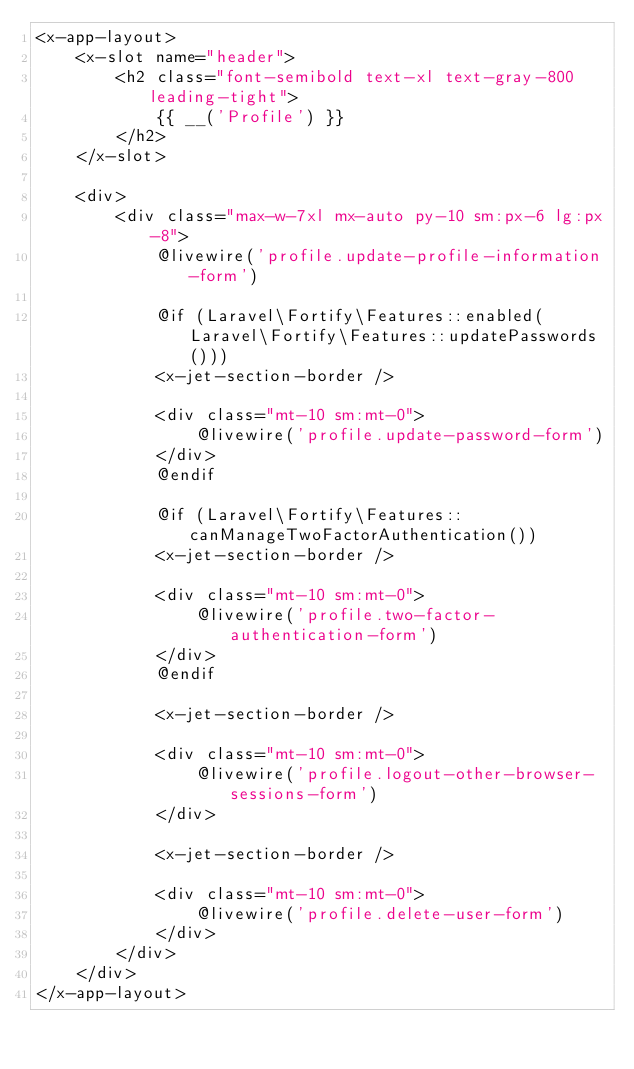Convert code to text. <code><loc_0><loc_0><loc_500><loc_500><_PHP_><x-app-layout>
    <x-slot name="header">
        <h2 class="font-semibold text-xl text-gray-800 leading-tight">
            {{ __('Profile') }}
        </h2>
    </x-slot>

    <div>
        <div class="max-w-7xl mx-auto py-10 sm:px-6 lg:px-8">
            @livewire('profile.update-profile-information-form')

            @if (Laravel\Fortify\Features::enabled(Laravel\Fortify\Features::updatePasswords()))
            <x-jet-section-border />

            <div class="mt-10 sm:mt-0">
                @livewire('profile.update-password-form')
            </div>
            @endif

            @if (Laravel\Fortify\Features::canManageTwoFactorAuthentication())
            <x-jet-section-border />

            <div class="mt-10 sm:mt-0">
                @livewire('profile.two-factor-authentication-form')
            </div>
            @endif

            <x-jet-section-border />

            <div class="mt-10 sm:mt-0">
                @livewire('profile.logout-other-browser-sessions-form')
            </div>

            <x-jet-section-border />

            <div class="mt-10 sm:mt-0">
                @livewire('profile.delete-user-form')
            </div>
        </div>
    </div>
</x-app-layout></code> 